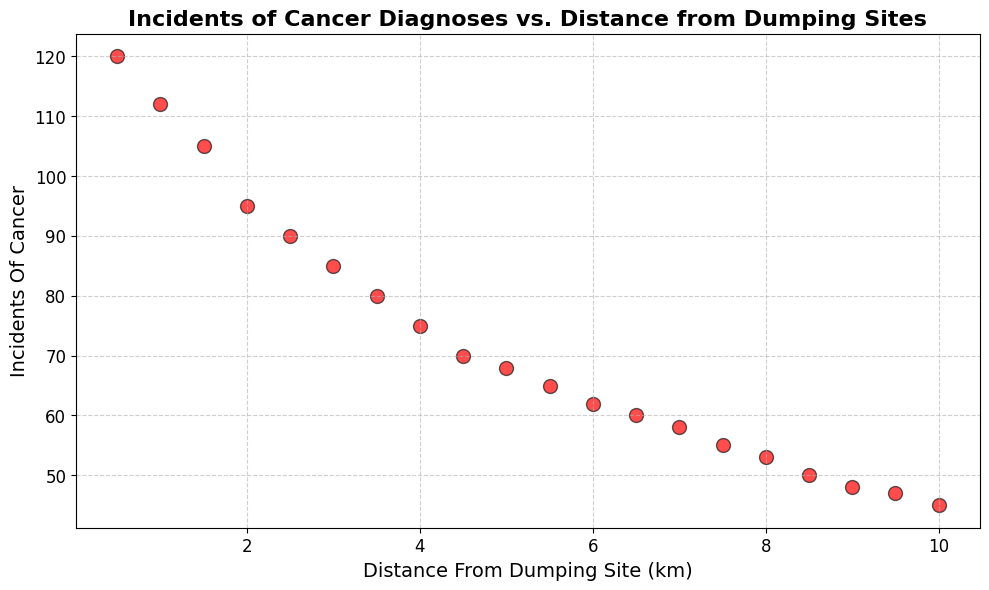What's the most frequent incident of cancer at 2.0 km distance from the dumping site? Look at the point on the scatter plot corresponding to the distance of 2.0 km, the y-value of that point represents the number of incidents of cancer. The y-value is 95.
Answer: 95 What is the general trend between the distance from the dumping site and the incidents of cancer? Observe the scatter plot: as the distance from the dumping site increases, the number of incidents of cancer generally decreases.
Answer: Decreasing trend Which distance has the lowest incidents of cancer diagnoses, and what is the value? Locate the point with the smallest y-value on the scatter plot. The lowest y-value on the plot appears at a distance of 10.0 km, which corresponds to 45 incidents.
Answer: 10.0 km, 45 How many more incidents of cancer are there at 1.5 km compared to 9.0 km? Find the y-values at 1.5 km and 9.0 km distances. The values are 105 and 48 respectively. Calculate the difference: 105 - 48 = 57.
Answer: 57 What is the difference in the number of cancer incidents between the distances of 0.5 km and 5.5 km? Look at the y-values at these distances. At 0.5 km, the value is 120, and at 5.5 km, it is 65. Calculate the difference: 120 - 65 = 55.
Answer: 55 Among the data points, which distance marks a notable change in the trend of cancer incidents? Examine the plot to identify points where the decline of incidents becomes more significant. The change may become notable around 2.5 km since the slope becomes steeper.
Answer: 2.5 km What is the combined total of cancer incidents at distances of 3.0 km, 7.5 km, and 9.5 km? Find the y-values at these distances: 3.0 km is 85, 7.5 km is 55, and 9.5 km is 47. Sum them: 85 + 55 + 47 = 187.
Answer: 187 How do the incidents at 4.0 km and 4.5 km compare? Is there a significant difference? Compare the y-values at 4.0 km (75 incidents) and 4.5 km (70 incidents). The difference is 75 - 70 = 5. The difference is not very significant.
Answer: Not significant What is the average number of cancer incidents at the distances 1.0 km, 3.5 km, and 6.0 km? Find the y-values at these distances: 1.0 km is 112, 3.5 km is 80, and 6.0 km is 62. Compute the average: (112 + 80 + 62) / 3 = 254 / 3 ≈ 84.67.
Answer: ≈ 84.67 Which two adjacent distances have the largest drop in cancer incidents? Compare differences in y-values between consecutive distances. The largest drop appears between 0.5 km (120 incidents) and 1.0 km (112 incidents), which is 120 - 112 = 8.
Answer: 0.5 km and 1.0 km 